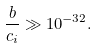Convert formula to latex. <formula><loc_0><loc_0><loc_500><loc_500>\frac { b } { c _ { i } } \gg 1 0 ^ { - 3 2 } .</formula> 